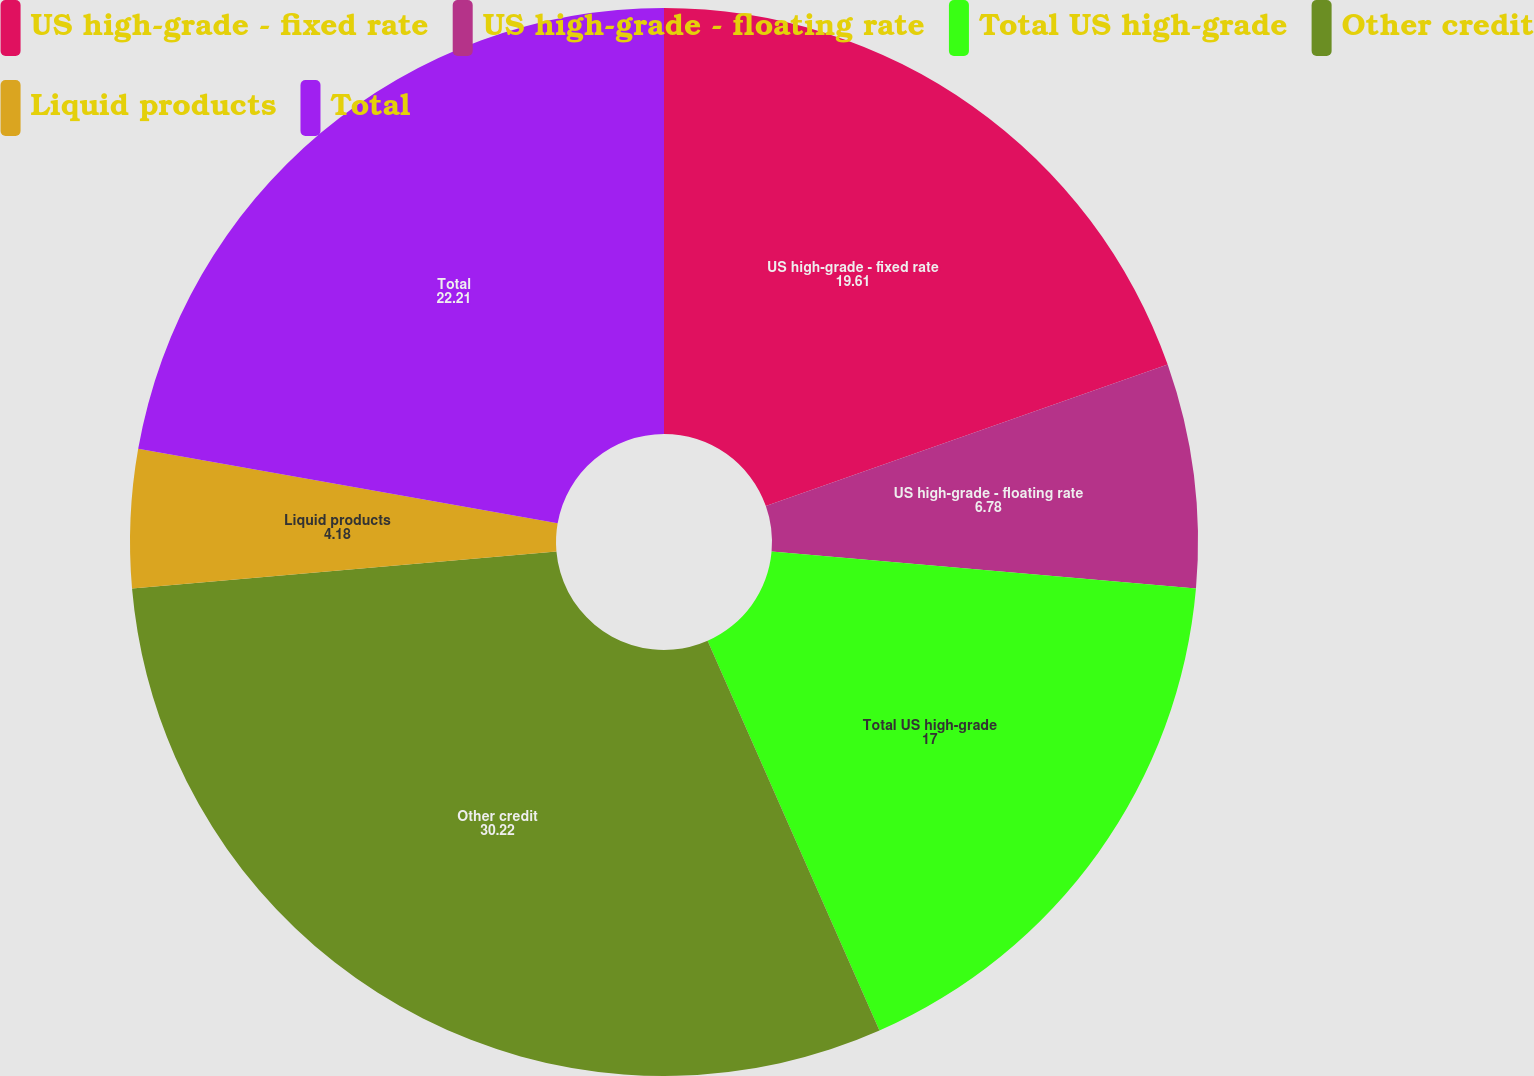Convert chart to OTSL. <chart><loc_0><loc_0><loc_500><loc_500><pie_chart><fcel>US high-grade - fixed rate<fcel>US high-grade - floating rate<fcel>Total US high-grade<fcel>Other credit<fcel>Liquid products<fcel>Total<nl><fcel>19.61%<fcel>6.78%<fcel>17.0%<fcel>30.22%<fcel>4.18%<fcel>22.21%<nl></chart> 